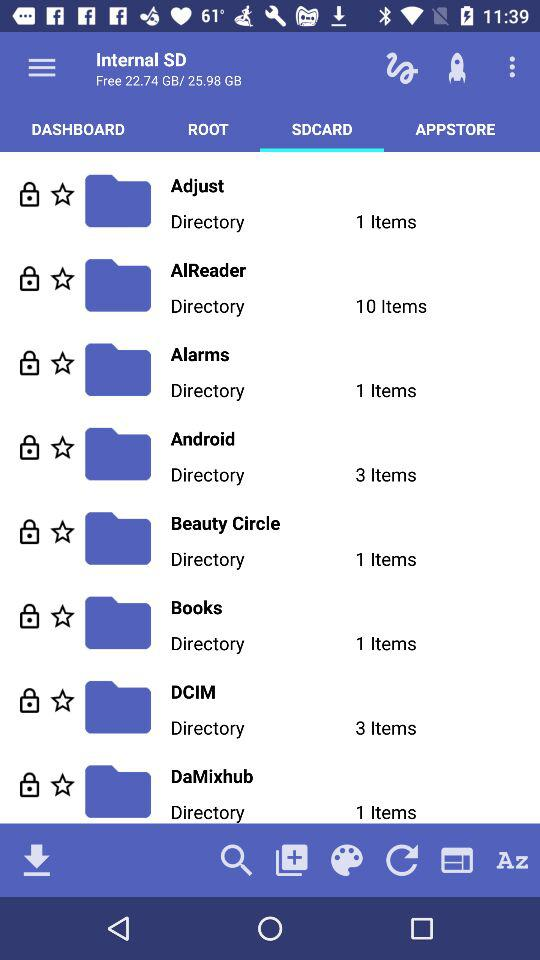How many items are in the "Books" directory? There is 1 item. 